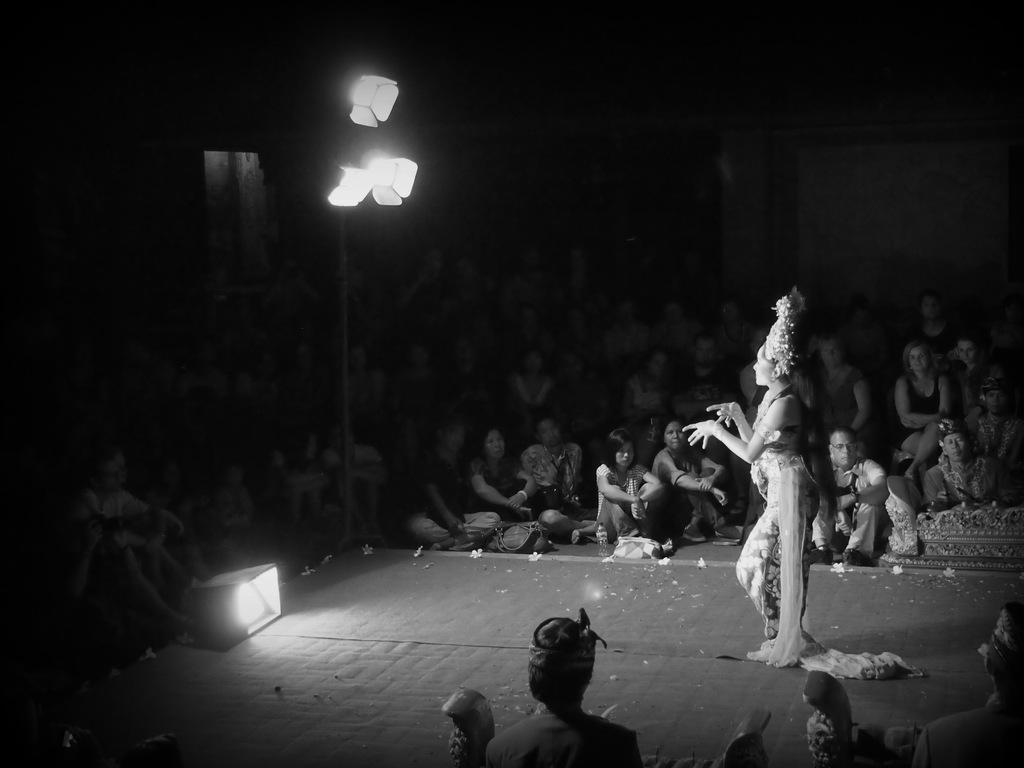In one or two sentences, can you explain what this image depicts? This is a black and white image. In this image we can see a woman standing on the stage. We can also see a light on the stage, some ceiling lights to a pole and a group of people sitting around her. 